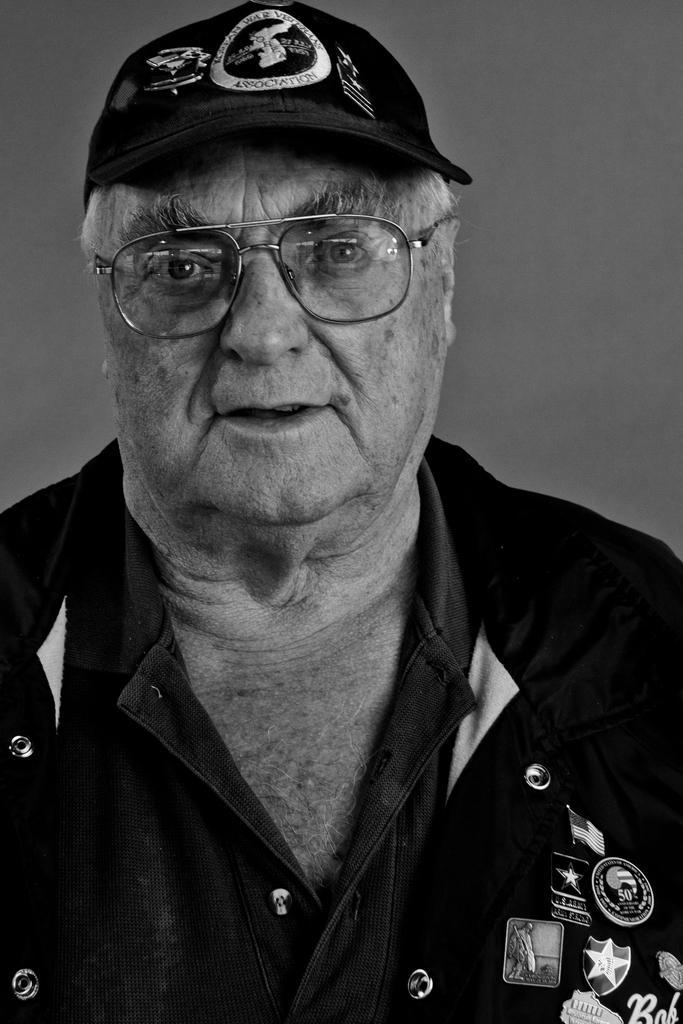Describe this image in one or two sentences. This image consists of a man wearing a black shirt and a black cap. The background is gray in color. 